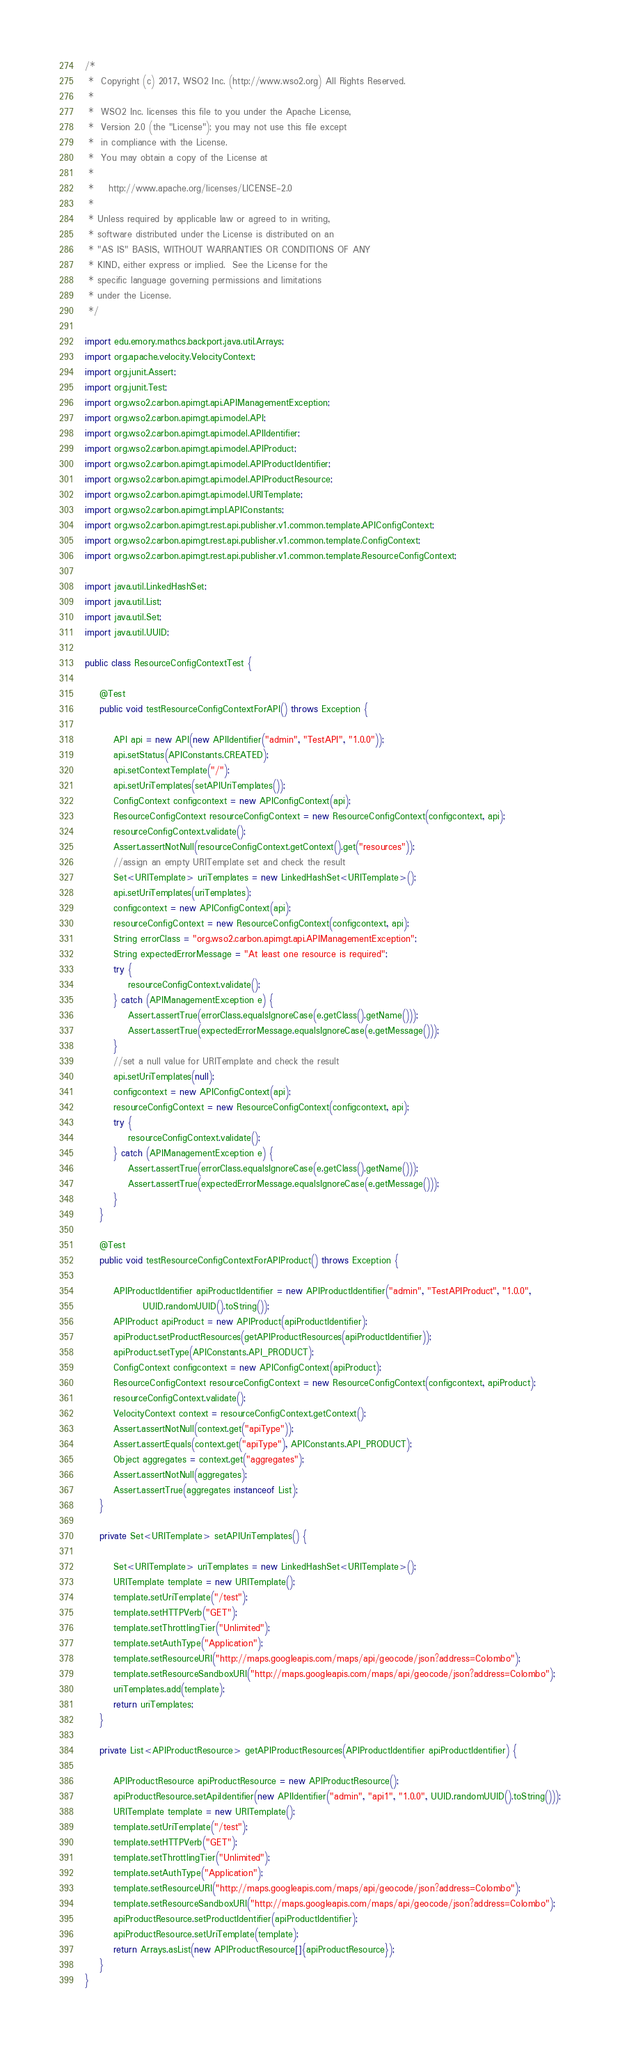Convert code to text. <code><loc_0><loc_0><loc_500><loc_500><_Java_>/*
 *  Copyright (c) 2017, WSO2 Inc. (http://www.wso2.org) All Rights Reserved.
 *
 *  WSO2 Inc. licenses this file to you under the Apache License,
 *  Version 2.0 (the "License"); you may not use this file except
 *  in compliance with the License.
 *  You may obtain a copy of the License at
 *
 *    http://www.apache.org/licenses/LICENSE-2.0
 *
 * Unless required by applicable law or agreed to in writing,
 * software distributed under the License is distributed on an
 * "AS IS" BASIS, WITHOUT WARRANTIES OR CONDITIONS OF ANY
 * KIND, either express or implied.  See the License for the
 * specific language governing permissions and limitations
 * under the License.
 */

import edu.emory.mathcs.backport.java.util.Arrays;
import org.apache.velocity.VelocityContext;
import org.junit.Assert;
import org.junit.Test;
import org.wso2.carbon.apimgt.api.APIManagementException;
import org.wso2.carbon.apimgt.api.model.API;
import org.wso2.carbon.apimgt.api.model.APIIdentifier;
import org.wso2.carbon.apimgt.api.model.APIProduct;
import org.wso2.carbon.apimgt.api.model.APIProductIdentifier;
import org.wso2.carbon.apimgt.api.model.APIProductResource;
import org.wso2.carbon.apimgt.api.model.URITemplate;
import org.wso2.carbon.apimgt.impl.APIConstants;
import org.wso2.carbon.apimgt.rest.api.publisher.v1.common.template.APIConfigContext;
import org.wso2.carbon.apimgt.rest.api.publisher.v1.common.template.ConfigContext;
import org.wso2.carbon.apimgt.rest.api.publisher.v1.common.template.ResourceConfigContext;

import java.util.LinkedHashSet;
import java.util.List;
import java.util.Set;
import java.util.UUID;

public class ResourceConfigContextTest {

    @Test
    public void testResourceConfigContextForAPI() throws Exception {

        API api = new API(new APIIdentifier("admin", "TestAPI", "1.0.0"));
        api.setStatus(APIConstants.CREATED);
        api.setContextTemplate("/");
        api.setUriTemplates(setAPIUriTemplates());
        ConfigContext configcontext = new APIConfigContext(api);
        ResourceConfigContext resourceConfigContext = new ResourceConfigContext(configcontext, api);
        resourceConfigContext.validate();
        Assert.assertNotNull(resourceConfigContext.getContext().get("resources"));
        //assign an empty URITemplate set and check the result
        Set<URITemplate> uriTemplates = new LinkedHashSet<URITemplate>();
        api.setUriTemplates(uriTemplates);
        configcontext = new APIConfigContext(api);
        resourceConfigContext = new ResourceConfigContext(configcontext, api);
        String errorClass = "org.wso2.carbon.apimgt.api.APIManagementException";
        String expectedErrorMessage = "At least one resource is required";
        try {
            resourceConfigContext.validate();
        } catch (APIManagementException e) {
            Assert.assertTrue(errorClass.equalsIgnoreCase(e.getClass().getName()));
            Assert.assertTrue(expectedErrorMessage.equalsIgnoreCase(e.getMessage()));
        }
        //set a null value for URITemplate and check the result
        api.setUriTemplates(null);
        configcontext = new APIConfigContext(api);
        resourceConfigContext = new ResourceConfigContext(configcontext, api);
        try {
            resourceConfigContext.validate();
        } catch (APIManagementException e) {
            Assert.assertTrue(errorClass.equalsIgnoreCase(e.getClass().getName()));
            Assert.assertTrue(expectedErrorMessage.equalsIgnoreCase(e.getMessage()));
        }
    }

    @Test
    public void testResourceConfigContextForAPIProduct() throws Exception {

        APIProductIdentifier apiProductIdentifier = new APIProductIdentifier("admin", "TestAPIProduct", "1.0.0",
                UUID.randomUUID().toString());
        APIProduct apiProduct = new APIProduct(apiProductIdentifier);
        apiProduct.setProductResources(getAPIProductResources(apiProductIdentifier));
        apiProduct.setType(APIConstants.API_PRODUCT);
        ConfigContext configcontext = new APIConfigContext(apiProduct);
        ResourceConfigContext resourceConfigContext = new ResourceConfigContext(configcontext, apiProduct);
        resourceConfigContext.validate();
        VelocityContext context = resourceConfigContext.getContext();
        Assert.assertNotNull(context.get("apiType"));
        Assert.assertEquals(context.get("apiType"), APIConstants.API_PRODUCT);
        Object aggregates = context.get("aggregates");
        Assert.assertNotNull(aggregates);
        Assert.assertTrue(aggregates instanceof List);
    }

    private Set<URITemplate> setAPIUriTemplates() {

        Set<URITemplate> uriTemplates = new LinkedHashSet<URITemplate>();
        URITemplate template = new URITemplate();
        template.setUriTemplate("/test");
        template.setHTTPVerb("GET");
        template.setThrottlingTier("Unlimited");
        template.setAuthType("Application");
        template.setResourceURI("http://maps.googleapis.com/maps/api/geocode/json?address=Colombo");
        template.setResourceSandboxURI("http://maps.googleapis.com/maps/api/geocode/json?address=Colombo");
        uriTemplates.add(template);
        return uriTemplates;
    }

    private List<APIProductResource> getAPIProductResources(APIProductIdentifier apiProductIdentifier) {

        APIProductResource apiProductResource = new APIProductResource();
        apiProductResource.setApiIdentifier(new APIIdentifier("admin", "api1", "1.0.0", UUID.randomUUID().toString()));
        URITemplate template = new URITemplate();
        template.setUriTemplate("/test");
        template.setHTTPVerb("GET");
        template.setThrottlingTier("Unlimited");
        template.setAuthType("Application");
        template.setResourceURI("http://maps.googleapis.com/maps/api/geocode/json?address=Colombo");
        template.setResourceSandboxURI("http://maps.googleapis.com/maps/api/geocode/json?address=Colombo");
        apiProductResource.setProductIdentifier(apiProductIdentifier);
        apiProductResource.setUriTemplate(template);
        return Arrays.asList(new APIProductResource[]{apiProductResource});
    }
}
</code> 